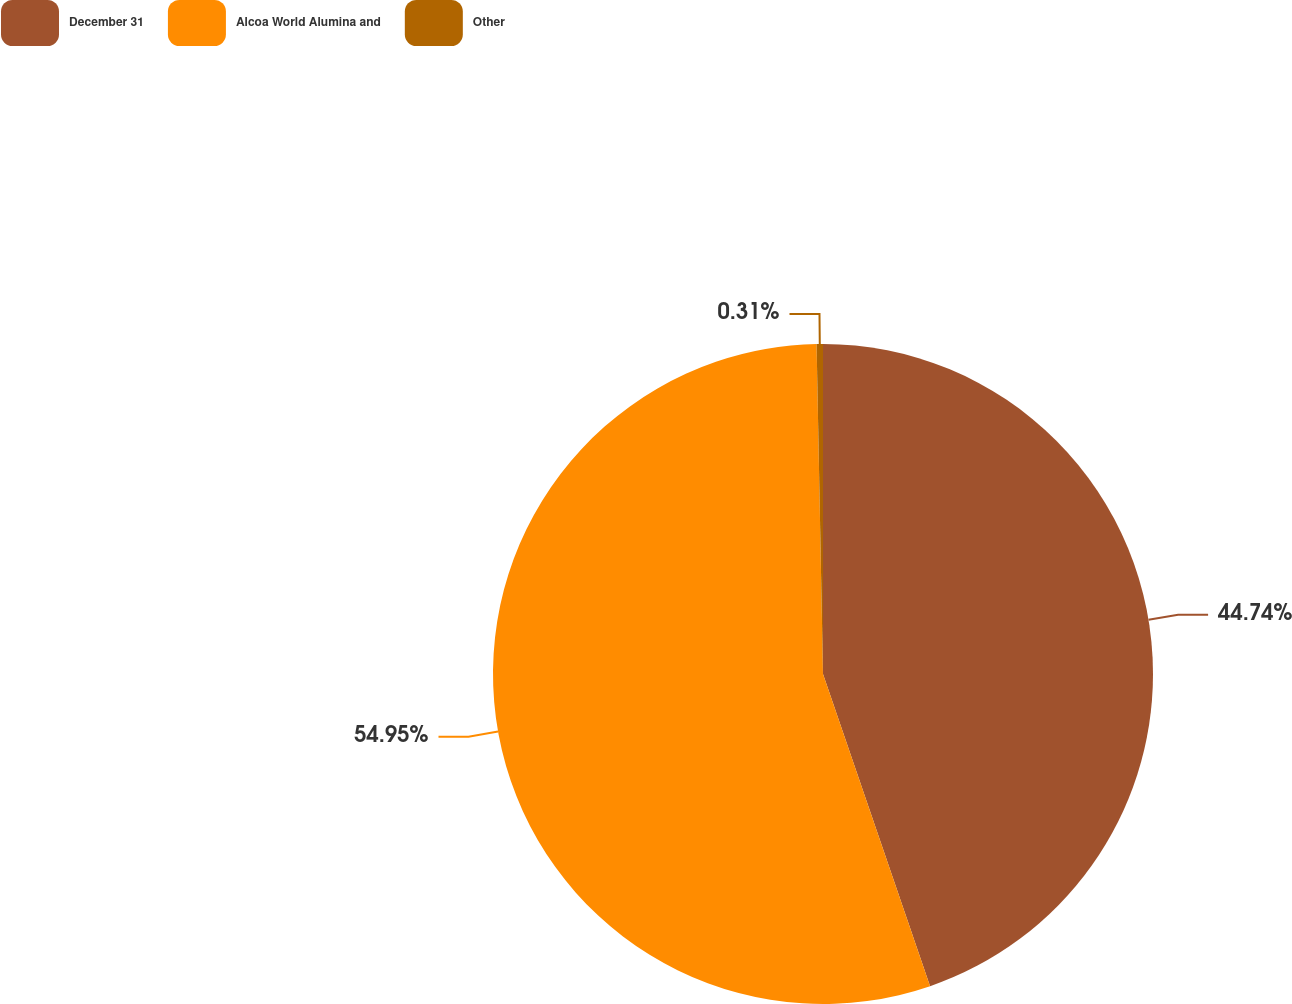Convert chart. <chart><loc_0><loc_0><loc_500><loc_500><pie_chart><fcel>December 31<fcel>Alcoa World Alumina and<fcel>Other<nl><fcel>44.74%<fcel>54.95%<fcel>0.31%<nl></chart> 